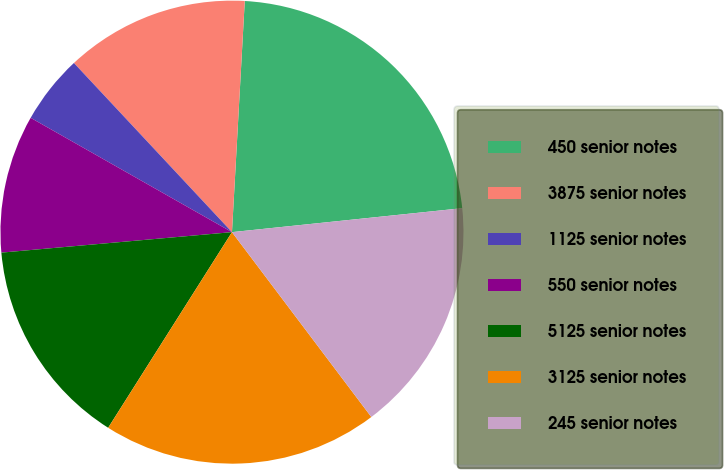<chart> <loc_0><loc_0><loc_500><loc_500><pie_chart><fcel>450 senior notes<fcel>3875 senior notes<fcel>1125 senior notes<fcel>550 senior notes<fcel>5125 senior notes<fcel>3125 senior notes<fcel>245 senior notes<nl><fcel>22.47%<fcel>12.84%<fcel>4.82%<fcel>9.63%<fcel>14.61%<fcel>19.26%<fcel>16.37%<nl></chart> 